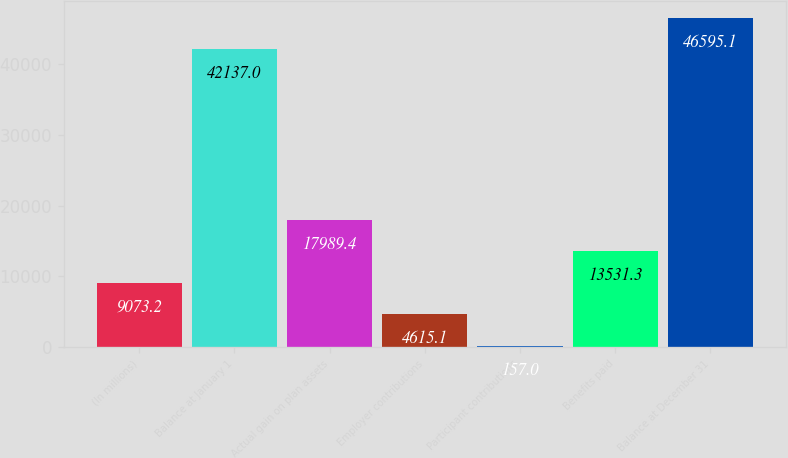<chart> <loc_0><loc_0><loc_500><loc_500><bar_chart><fcel>(In millions)<fcel>Balance at January 1<fcel>Actual gain on plan assets<fcel>Employer contributions<fcel>Participant contributions<fcel>Benefits paid<fcel>Balance at December 31<nl><fcel>9073.2<fcel>42137<fcel>17989.4<fcel>4615.1<fcel>157<fcel>13531.3<fcel>46595.1<nl></chart> 